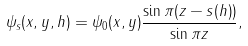Convert formula to latex. <formula><loc_0><loc_0><loc_500><loc_500>\psi _ { s } ( x , y , h ) = \psi _ { 0 } ( x , y ) \frac { \sin { \pi ( z - s ( h ) ) } } { \sin { \pi z } } ,</formula> 